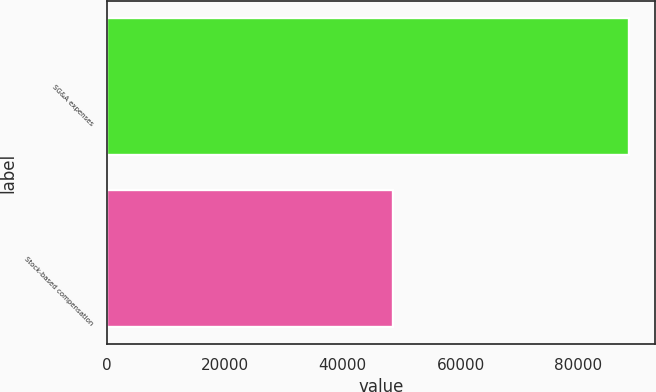Convert chart. <chart><loc_0><loc_0><loc_500><loc_500><bar_chart><fcel>SG&A expenses<fcel>Stock-based compensation<nl><fcel>88603<fcel>48449<nl></chart> 